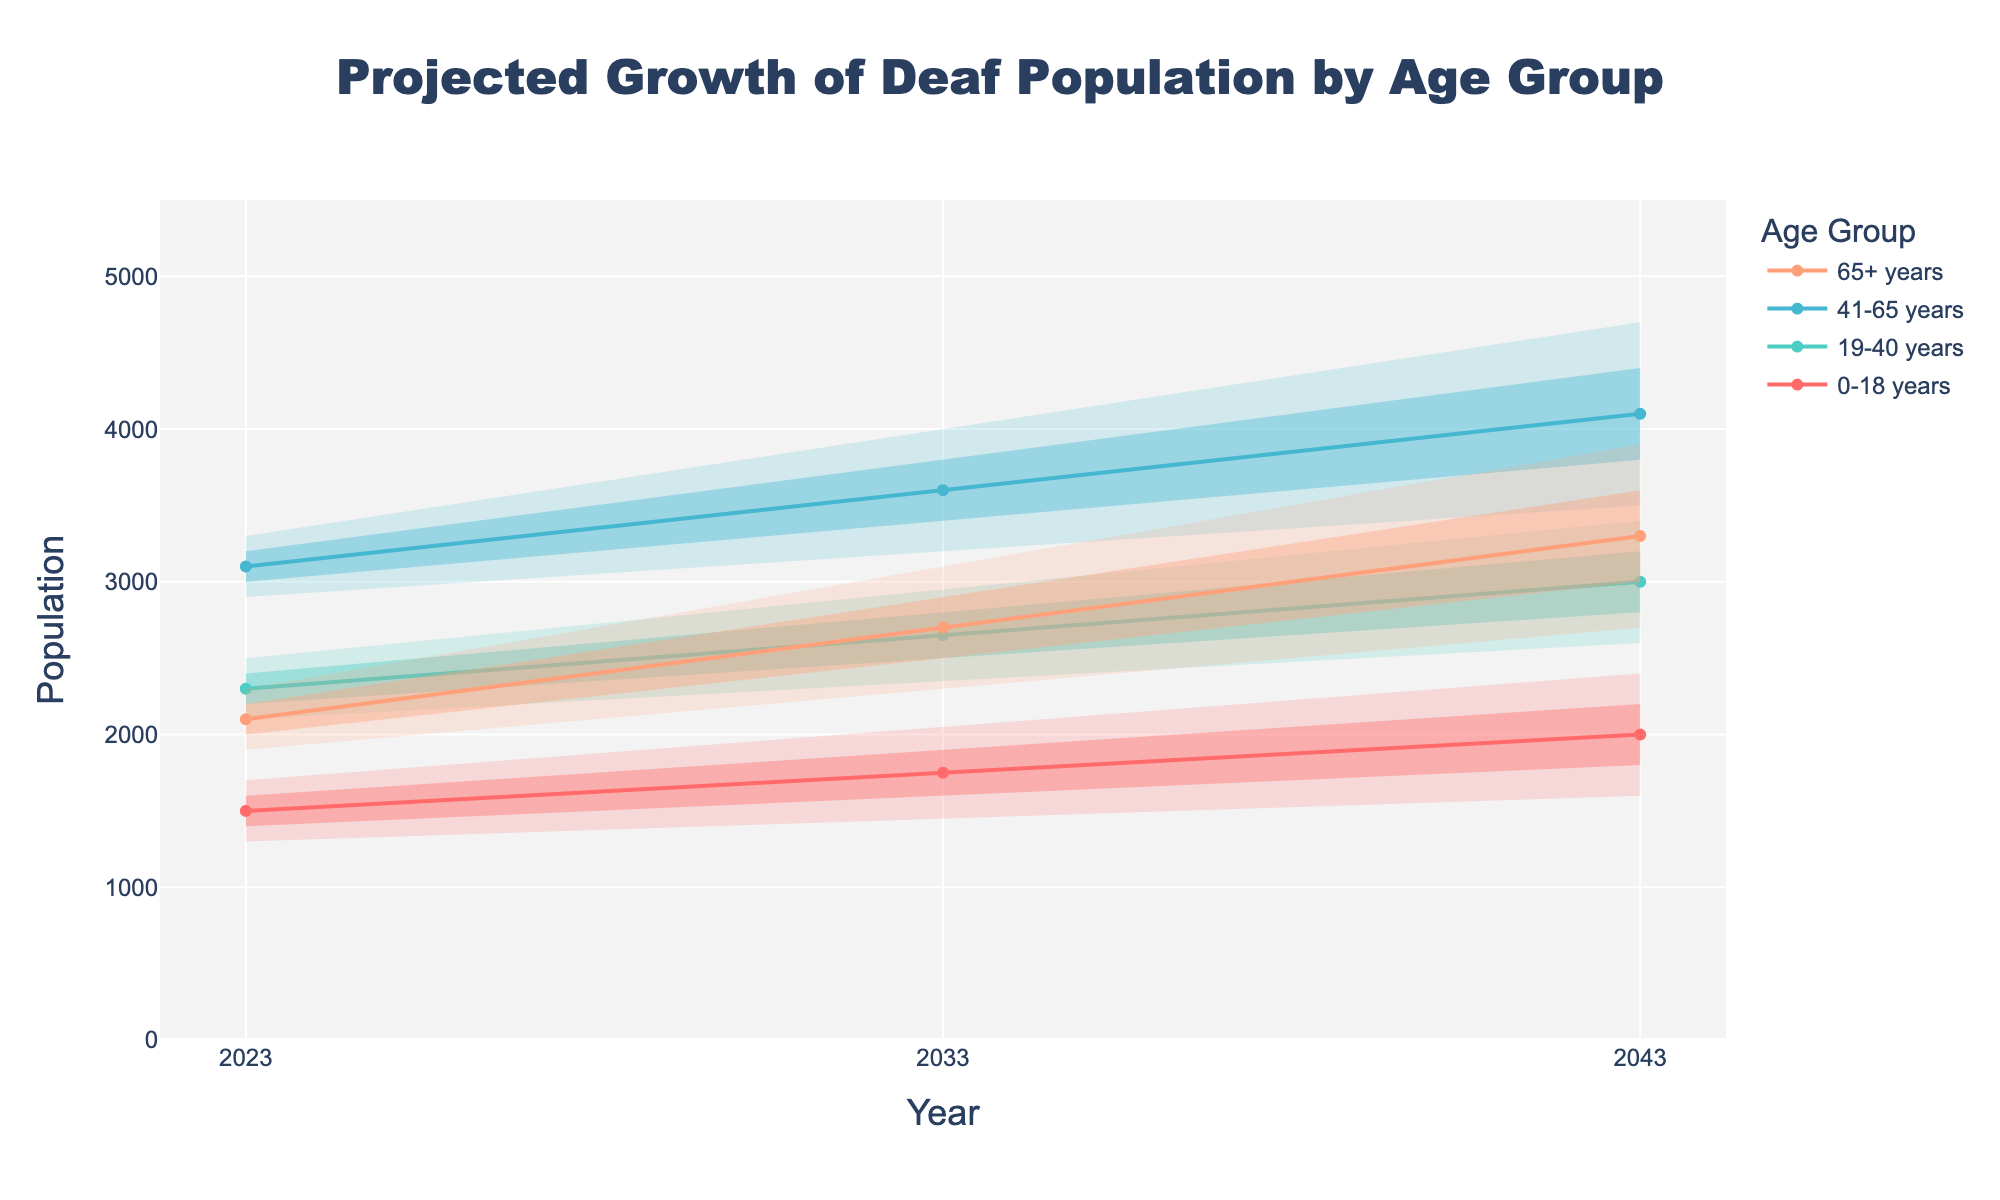How many age groups are shown in the chart? The chart has four colored lines, each representing a different age group. The text adjacent to these lines indicates the specific age groups: 0-18, 19-40, 41-65, and 65+.
Answer: Four What is the projected median population of deaf individuals aged 65+ in 2043? Locate the line corresponding to the 65+ age group and trace it to the year 2043. The median value for this year for this age group is 3300.
Answer: 3300 Which age group is projected to have the largest median increase in population from 2023 to 2043? Compare the median values of each age group for the years 2023 and 2043. The age group 41-65 shows the largest increase from 3100 in 2023 to 4100 in 2043, resulting in an increase of 1000.
Answer: 41-65 By how much is the 75th percentile value of the 0-18 age group projected to increase from 2033 to 2043? For the 0-18 age group, locate the 75th percentile in 2033 and 2043. The values are 1900 in 2033 and 2200 in 2043. The increase is 2200 - 1900 = 300.
Answer: 300 In which year and for which age group is the upper bound projected to be the highest? Inspect the upper bounds for each age group across all years. The highest upper bound projection is found in the 41-65 age group in the year 2043, and it is 5000.
Answer: 2043, 41-65 What is the projected lower bound of the 19-40 age group in 2033? For the 19-40 age group, locate the lower bound value for the year 2033. The figure shows this value as 2200.
Answer: 2200 Which age group shows the smallest projected increase in median population from 2023 to 2033? Compare the median values for each age group between 2023 and 2033. The 19-40 age group's median value increases from 2300 to 2650, making the increase 350 the smallest among the age groups.
Answer: 19-40 Is the projected median population for the 0-18 age group higher than the lower bound of the 19-40 age group in 2043? Compare the median of the 0-18 age group in 2043 with the lower bound of the 19-40 age group in 2043. The 0-18 median is 2000, and the 19-40 lower bound is 2400. This shows the median is not higher.
Answer: No 